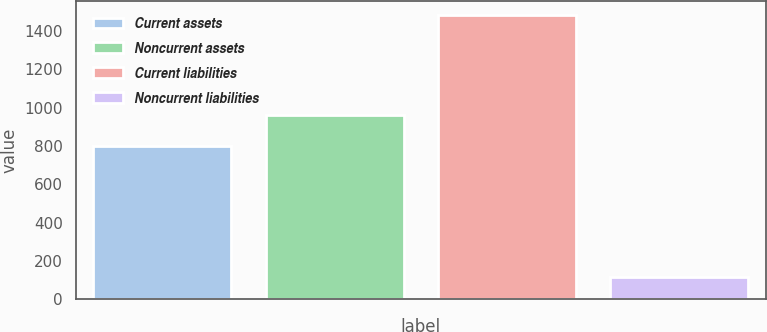Convert chart to OTSL. <chart><loc_0><loc_0><loc_500><loc_500><bar_chart><fcel>Current assets<fcel>Noncurrent assets<fcel>Current liabilities<fcel>Noncurrent liabilities<nl><fcel>800.1<fcel>962.1<fcel>1484.8<fcel>118.2<nl></chart> 